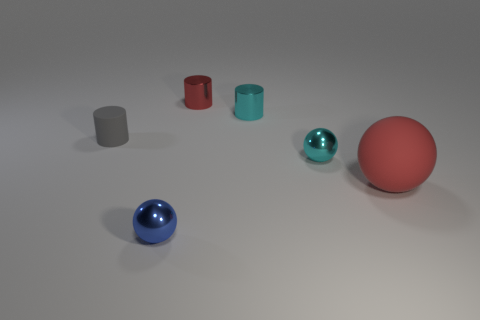What color is the rubber object that is on the right side of the small gray cylinder?
Give a very brief answer. Red. Is there a tiny cyan ball behind the small ball that is left of the cyan cylinder?
Give a very brief answer. Yes. Does the small metallic object that is in front of the large rubber object have the same color as the small sphere that is behind the large sphere?
Your answer should be compact. No. There is a big red object; what number of rubber cylinders are in front of it?
Provide a succinct answer. 0. How many other rubber balls have the same color as the big sphere?
Make the answer very short. 0. Does the cylinder in front of the tiny cyan metallic cylinder have the same material as the red cylinder?
Provide a succinct answer. No. What number of big red objects have the same material as the small gray cylinder?
Offer a very short reply. 1. Is the number of tiny matte objects that are in front of the tiny gray cylinder greater than the number of small cyan objects?
Your answer should be very brief. No. There is another object that is the same color as the large thing; what size is it?
Give a very brief answer. Small. Is there another metallic object of the same shape as the blue metallic thing?
Provide a succinct answer. Yes. 